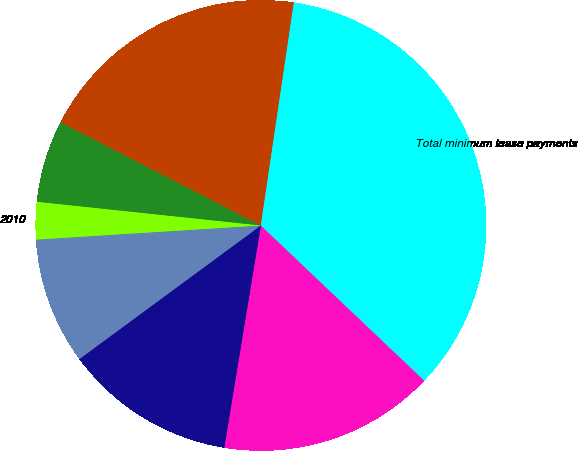Convert chart. <chart><loc_0><loc_0><loc_500><loc_500><pie_chart><fcel>2007<fcel>2008<fcel>2009<fcel>2010<fcel>2011<fcel>Later Years<fcel>Total minimum lease payments<nl><fcel>15.51%<fcel>12.3%<fcel>9.1%<fcel>2.68%<fcel>5.89%<fcel>19.77%<fcel>34.75%<nl></chart> 